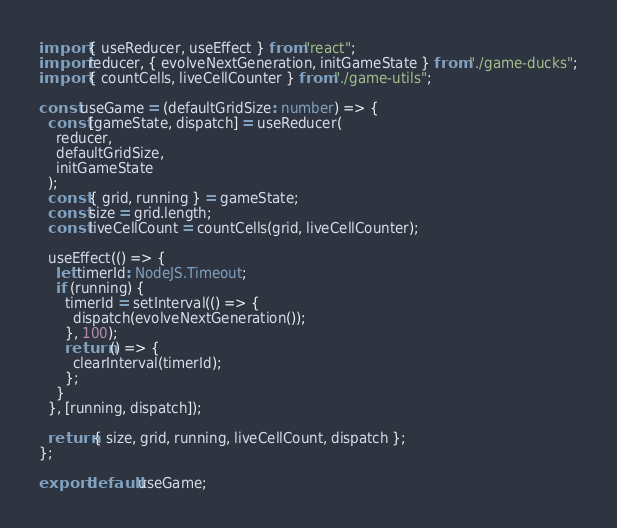<code> <loc_0><loc_0><loc_500><loc_500><_TypeScript_>import { useReducer, useEffect } from "react";
import reducer, { evolveNextGeneration, initGameState } from "./game-ducks";
import { countCells, liveCellCounter } from "./game-utils";

const useGame = (defaultGridSize: number) => {
  const [gameState, dispatch] = useReducer(
    reducer,
    defaultGridSize,
    initGameState
  );
  const { grid, running } = gameState;
  const size = grid.length;
  const liveCellCount = countCells(grid, liveCellCounter);

  useEffect(() => {
    let timerId: NodeJS.Timeout;
    if (running) {
      timerId = setInterval(() => {
        dispatch(evolveNextGeneration());
      }, 100);
      return () => {
        clearInterval(timerId);
      };
    }
  }, [running, dispatch]);

  return { size, grid, running, liveCellCount, dispatch };
};

export default useGame;
</code> 